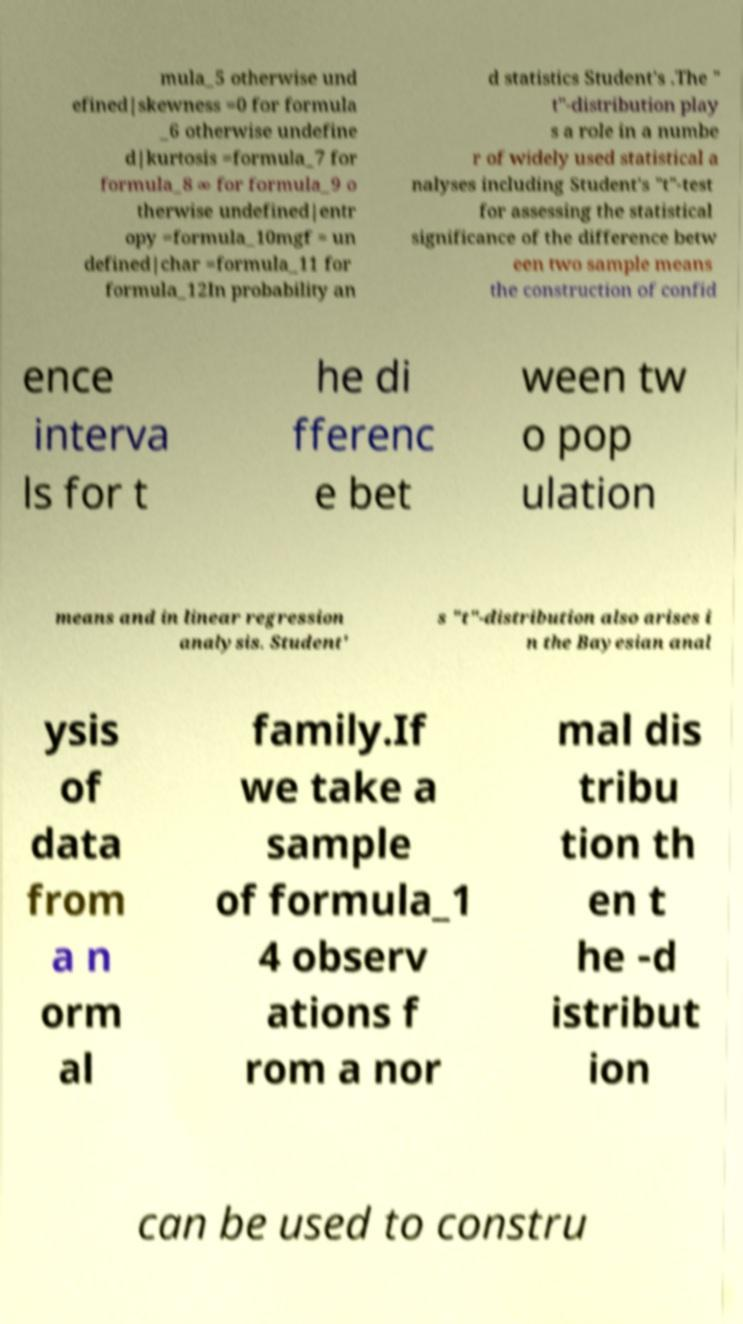Could you extract and type out the text from this image? mula_5 otherwise und efined|skewness =0 for formula _6 otherwise undefine d|kurtosis =formula_7 for formula_8 ∞ for formula_9 o therwise undefined|entr opy =formula_10mgf = un defined|char =formula_11 for formula_12In probability an d statistics Student's .The " t"-distribution play s a role in a numbe r of widely used statistical a nalyses including Student's "t"-test for assessing the statistical significance of the difference betw een two sample means the construction of confid ence interva ls for t he di fferenc e bet ween tw o pop ulation means and in linear regression analysis. Student' s "t"-distribution also arises i n the Bayesian anal ysis of data from a n orm al family.If we take a sample of formula_1 4 observ ations f rom a nor mal dis tribu tion th en t he -d istribut ion can be used to constru 